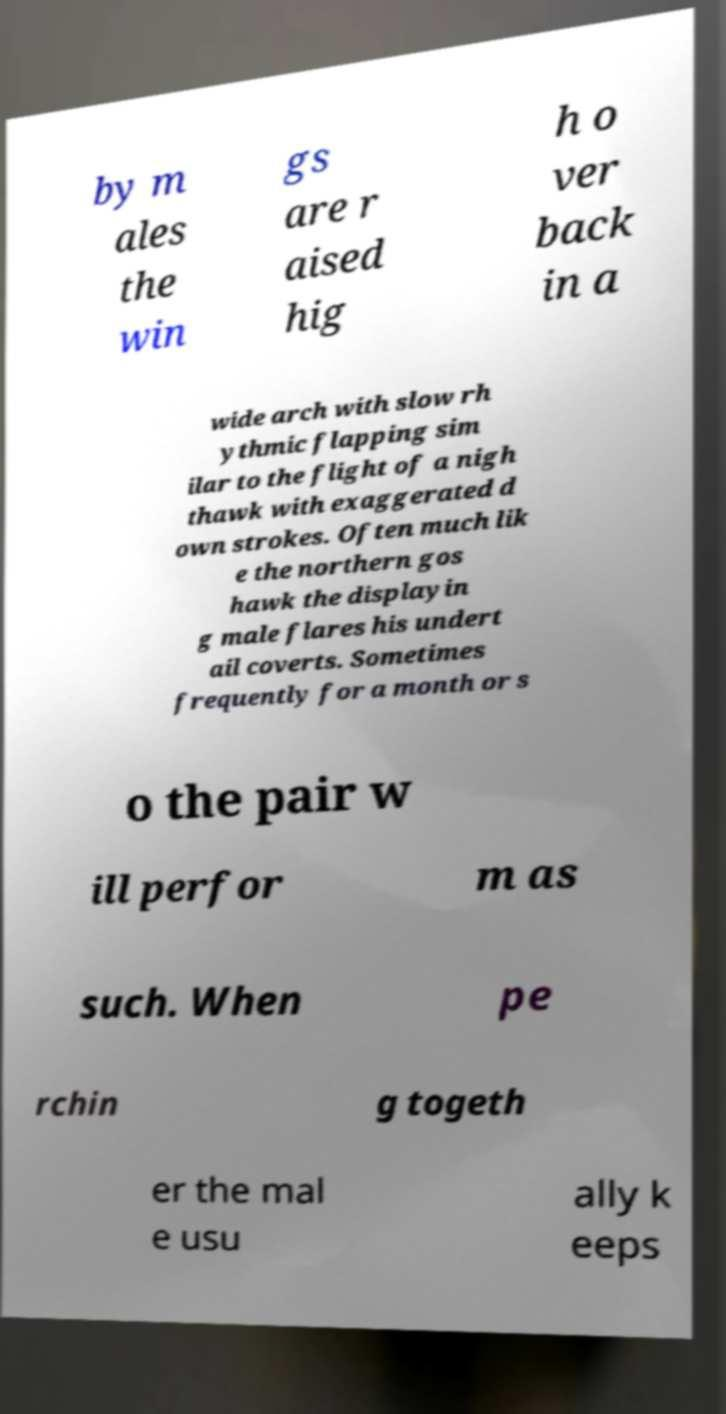Please read and relay the text visible in this image. What does it say? by m ales the win gs are r aised hig h o ver back in a wide arch with slow rh ythmic flapping sim ilar to the flight of a nigh thawk with exaggerated d own strokes. Often much lik e the northern gos hawk the displayin g male flares his undert ail coverts. Sometimes frequently for a month or s o the pair w ill perfor m as such. When pe rchin g togeth er the mal e usu ally k eeps 